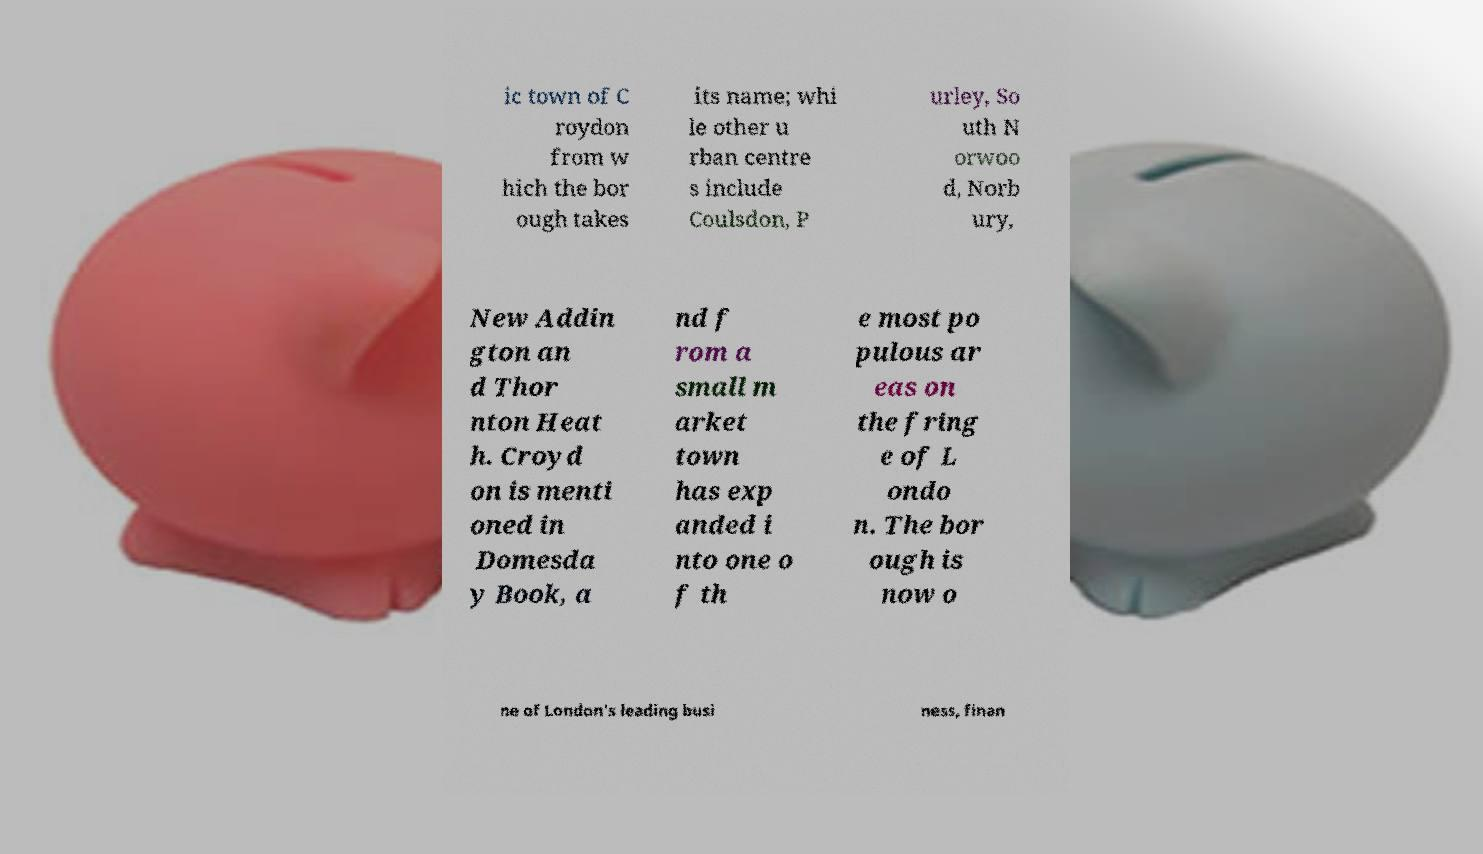Could you assist in decoding the text presented in this image and type it out clearly? ic town of C roydon from w hich the bor ough takes its name; whi le other u rban centre s include Coulsdon, P urley, So uth N orwoo d, Norb ury, New Addin gton an d Thor nton Heat h. Croyd on is menti oned in Domesda y Book, a nd f rom a small m arket town has exp anded i nto one o f th e most po pulous ar eas on the fring e of L ondo n. The bor ough is now o ne of London's leading busi ness, finan 